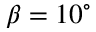<formula> <loc_0><loc_0><loc_500><loc_500>\beta = 1 0 ^ { \circ }</formula> 